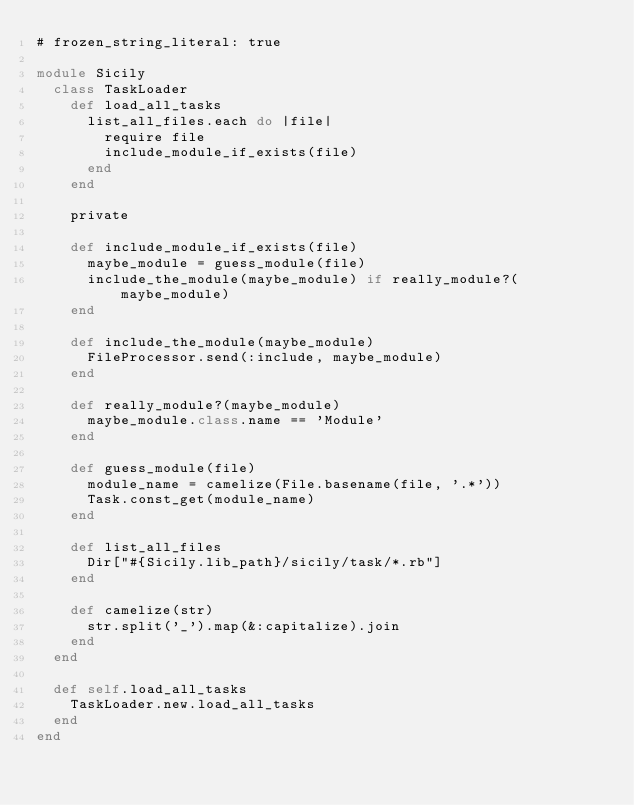Convert code to text. <code><loc_0><loc_0><loc_500><loc_500><_Ruby_># frozen_string_literal: true

module Sicily
  class TaskLoader
    def load_all_tasks
      list_all_files.each do |file|
        require file
        include_module_if_exists(file)
      end
    end

    private

    def include_module_if_exists(file)
      maybe_module = guess_module(file)
      include_the_module(maybe_module) if really_module?(maybe_module)
    end

    def include_the_module(maybe_module)
      FileProcessor.send(:include, maybe_module)
    end

    def really_module?(maybe_module)
      maybe_module.class.name == 'Module'
    end

    def guess_module(file)
      module_name = camelize(File.basename(file, '.*'))
      Task.const_get(module_name)
    end

    def list_all_files
      Dir["#{Sicily.lib_path}/sicily/task/*.rb"]
    end

    def camelize(str)
      str.split('_').map(&:capitalize).join
    end
  end

  def self.load_all_tasks
    TaskLoader.new.load_all_tasks
  end
end
</code> 